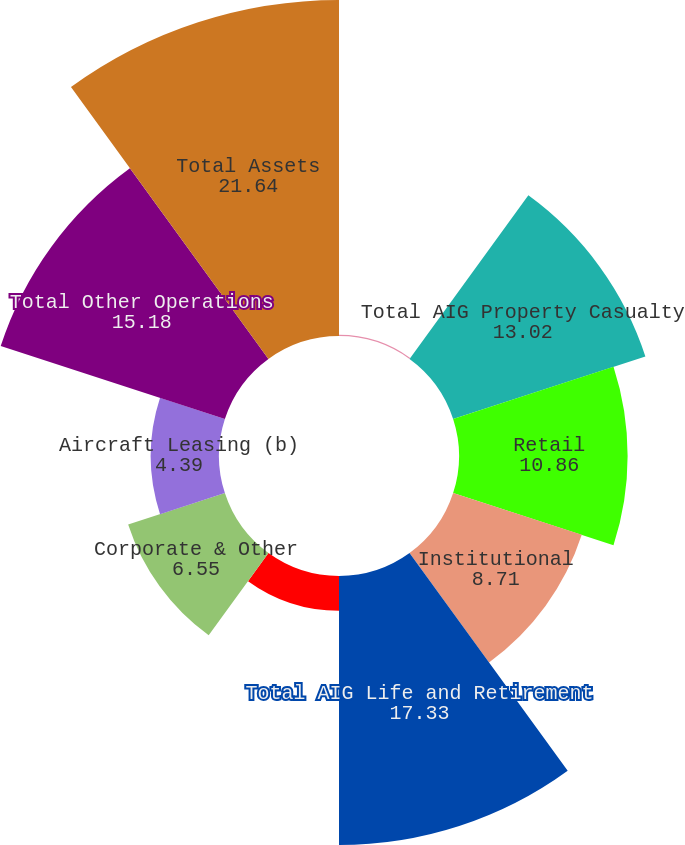Convert chart to OTSL. <chart><loc_0><loc_0><loc_500><loc_500><pie_chart><fcel>(in millions)<fcel>Total AIG Property Casualty<fcel>Retail<fcel>Institutional<fcel>Total AIG Life and Retirement<fcel>Mortgage Guaranty<fcel>Corporate & Other<fcel>Aircraft Leasing (b)<fcel>Total Other Operations<fcel>Total Assets<nl><fcel>0.08%<fcel>13.02%<fcel>10.86%<fcel>8.71%<fcel>17.33%<fcel>2.24%<fcel>6.55%<fcel>4.39%<fcel>15.18%<fcel>21.64%<nl></chart> 